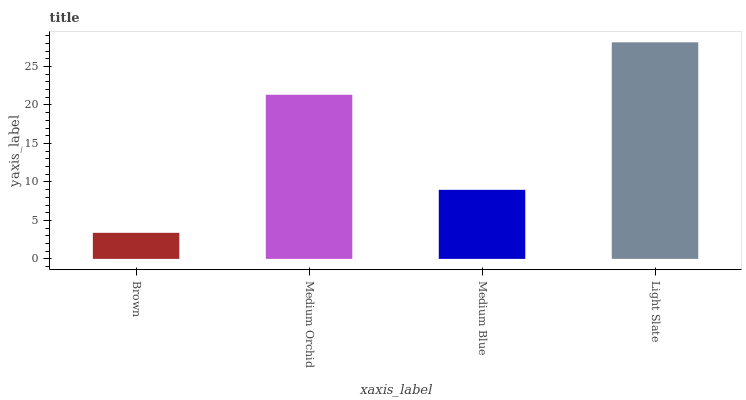Is Brown the minimum?
Answer yes or no. Yes. Is Light Slate the maximum?
Answer yes or no. Yes. Is Medium Orchid the minimum?
Answer yes or no. No. Is Medium Orchid the maximum?
Answer yes or no. No. Is Medium Orchid greater than Brown?
Answer yes or no. Yes. Is Brown less than Medium Orchid?
Answer yes or no. Yes. Is Brown greater than Medium Orchid?
Answer yes or no. No. Is Medium Orchid less than Brown?
Answer yes or no. No. Is Medium Orchid the high median?
Answer yes or no. Yes. Is Medium Blue the low median?
Answer yes or no. Yes. Is Light Slate the high median?
Answer yes or no. No. Is Medium Orchid the low median?
Answer yes or no. No. 